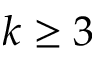Convert formula to latex. <formula><loc_0><loc_0><loc_500><loc_500>k \geq 3</formula> 